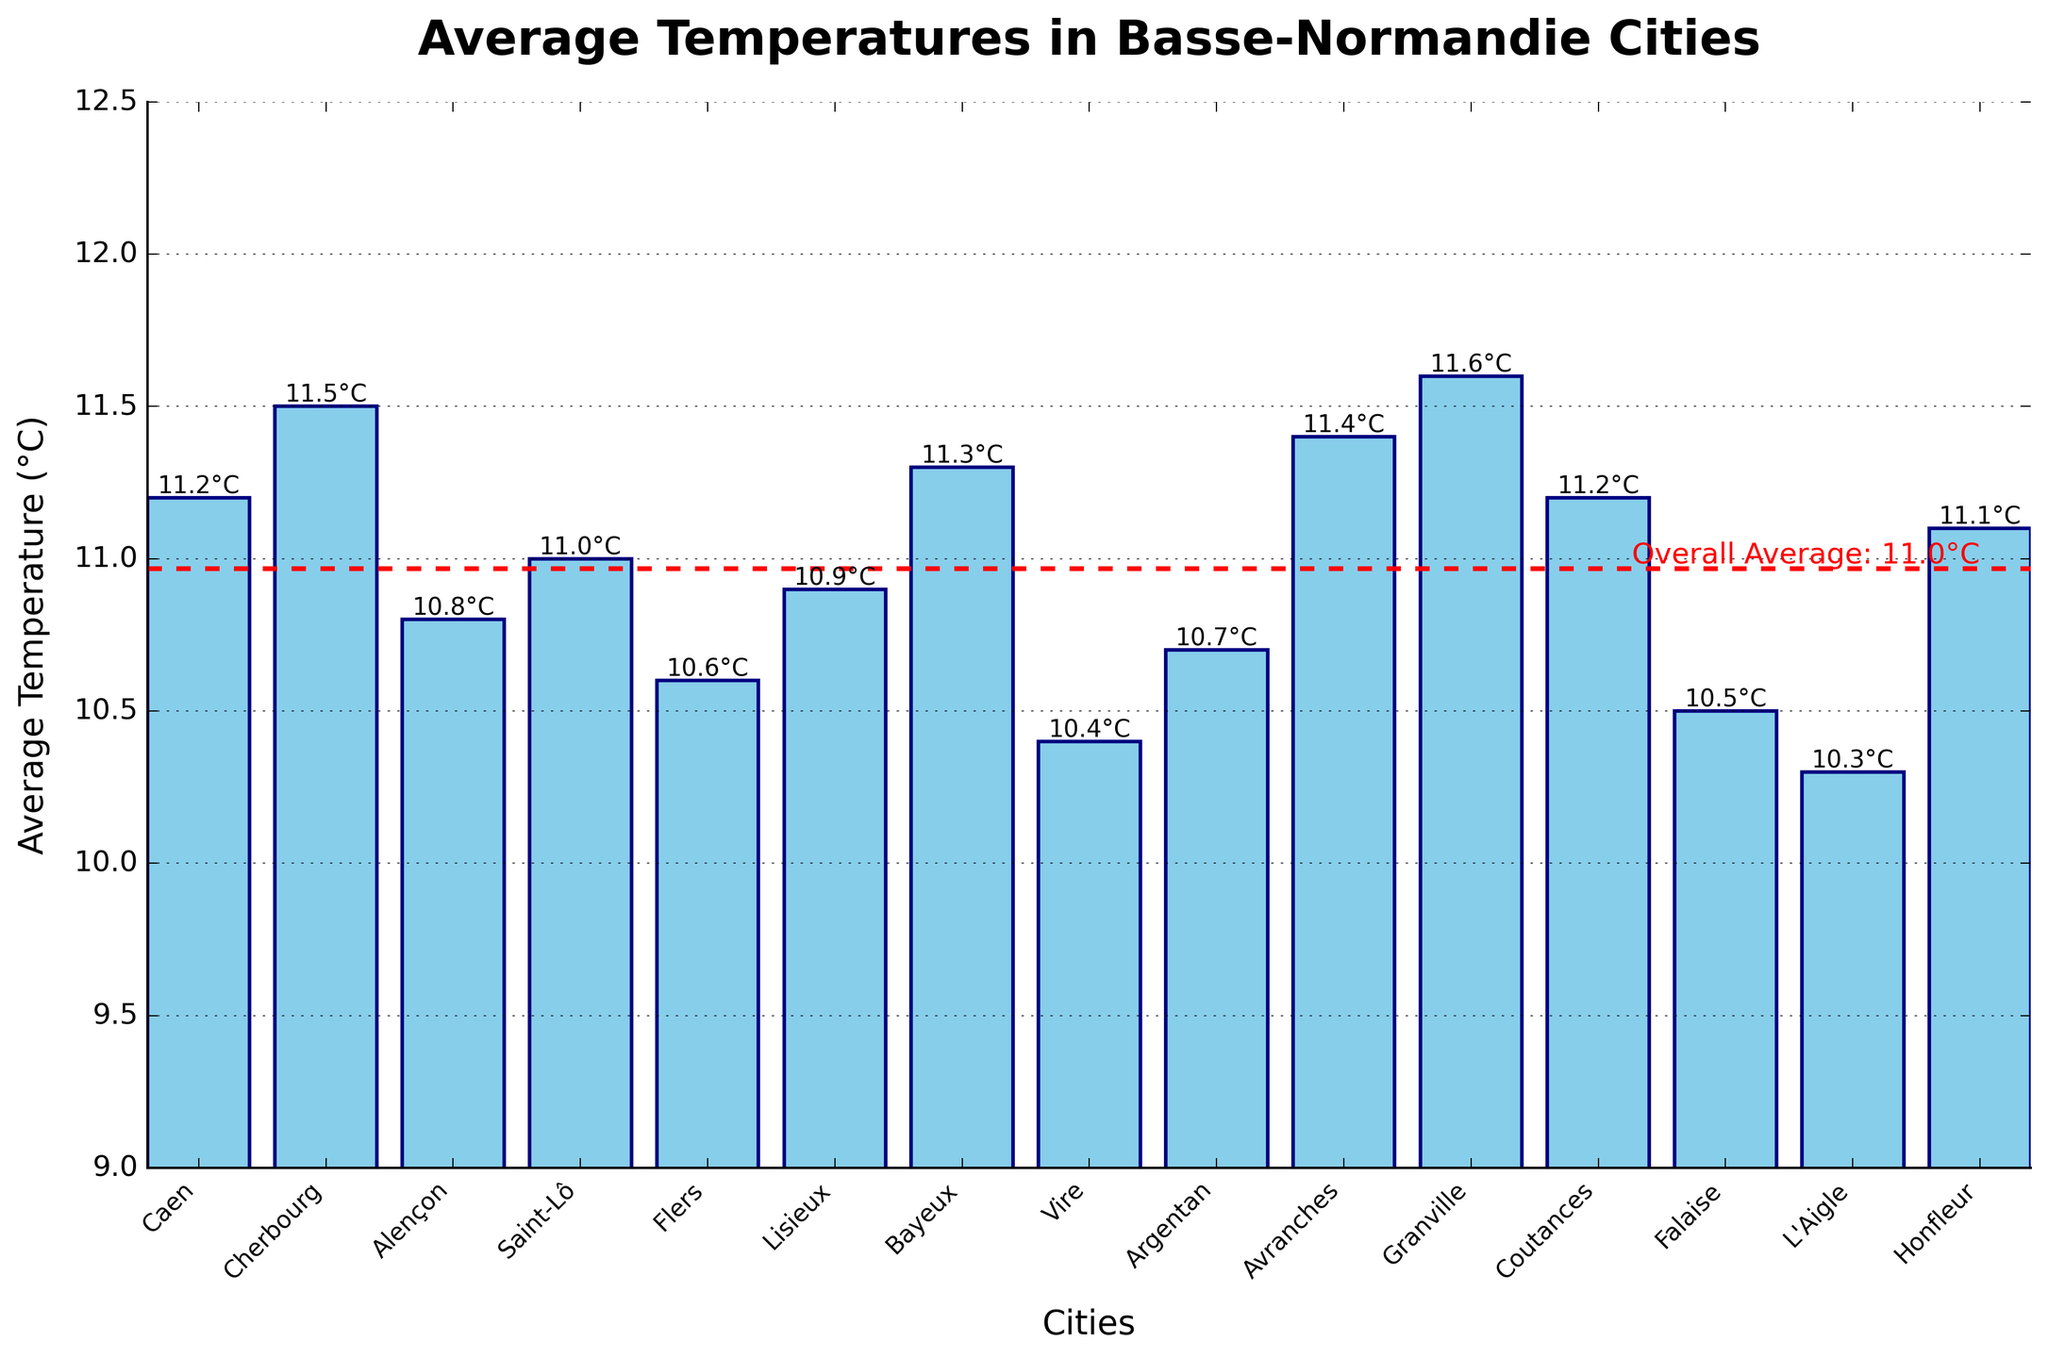Which city has the highest average temperature? By looking at the bar heights, identify the tallest bar which corresponds to the city with the highest average temperature.
Answer: Granville What is the difference in average temperature between the warmest and the coldest city? The warmest city is Granville with 11.6°C, and the coldest city is L'Aigle with 10.3°C. The difference is calculated as 11.6 - 10.3.
Answer: 1.3°C How does the average temperature in Cherbourg compare to that of Caen? Find the bars for Cherbourg and Caen, observe their heights, and compare. Cherbourg's average temperature is 11.5°C and Caen's is 11.2°C, so Cherbourg is slightly warmer.
Answer: Cherbourg is warmer What is the overall average temperature of the cities depicted in the chart? There is a horizontal red dashed line representing the overall average temperature of the cities, which is also marked with a label.
Answer: 11.0°C Which cities have an average temperature exactly equal to the overall average? Observe the bars that align with the overall average horizontal line (11.0°C). The cities are Saint-Lô and potentially others close to 11.0°C as crucial details.
Answer: Saint-Lô If you combine the temperatures of Argentan and Honfleur and find their average, would it be above or below the overall average? Sum the temperatures of Argentan (10.7°C) and Honfleur (11.1°C) and divide by 2 to find their average: (10.7 + 11.1) / 2 = 10.9°C. Compare this average to the overall average of 11.0°C.
Answer: Below Are there more cities with temperatures above or below the overall average? Count the number of bars above the red dashed line (11.0°C) and the number of bars below it.
Answer: Below Which city is closest in temperature to Falaise? Compare the bar height of Falaise (10.5°C) with its neighboring cities. Lisieux (10.9°C) and Flers (10.6°C) are close, but Flers is closer to 10.5°C.
Answer: Flers What is the sum of the temperatures for the three coldest cities? Identify the three cities with the lowest temperatures: L'Aigle (10.3°C), Vire (10.4°C), Falaise (10.5°C). Sum these temperatures: 10.3 + 10.4 + 10.5.
Answer: 31.2°C What is the range of temperatures across all the cities? The range is found by subtracting the lowest temperature (10.3°C in L'Aigle) from the highest temperature (11.6°C in Granville).
Answer: 1.3°C 